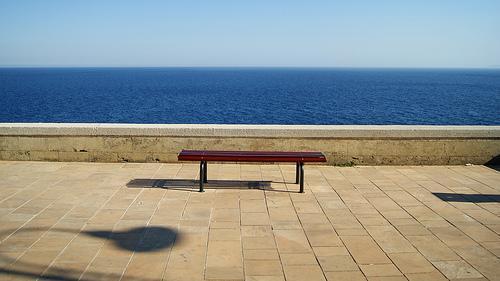How many people are there?
Give a very brief answer. 0. How many people are sitting on the chair?
Give a very brief answer. 0. 